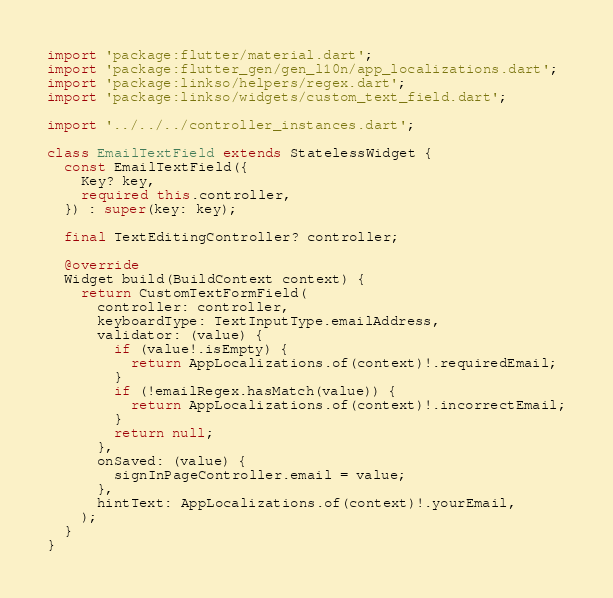Convert code to text. <code><loc_0><loc_0><loc_500><loc_500><_Dart_>import 'package:flutter/material.dart';
import 'package:flutter_gen/gen_l10n/app_localizations.dart';
import 'package:linkso/helpers/regex.dart';
import 'package:linkso/widgets/custom_text_field.dart';

import '../../../controller_instances.dart';

class EmailTextField extends StatelessWidget {
  const EmailTextField({
    Key? key,
    required this.controller,
  }) : super(key: key);

  final TextEditingController? controller;

  @override
  Widget build(BuildContext context) {
    return CustomTextFormField(
      controller: controller,
      keyboardType: TextInputType.emailAddress,
      validator: (value) {
        if (value!.isEmpty) {
          return AppLocalizations.of(context)!.requiredEmail;
        }
        if (!emailRegex.hasMatch(value)) {
          return AppLocalizations.of(context)!.incorrectEmail;
        }
        return null;
      },
      onSaved: (value) {
        signInPageController.email = value;
      },
      hintText: AppLocalizations.of(context)!.yourEmail,
    );
  }
}
</code> 